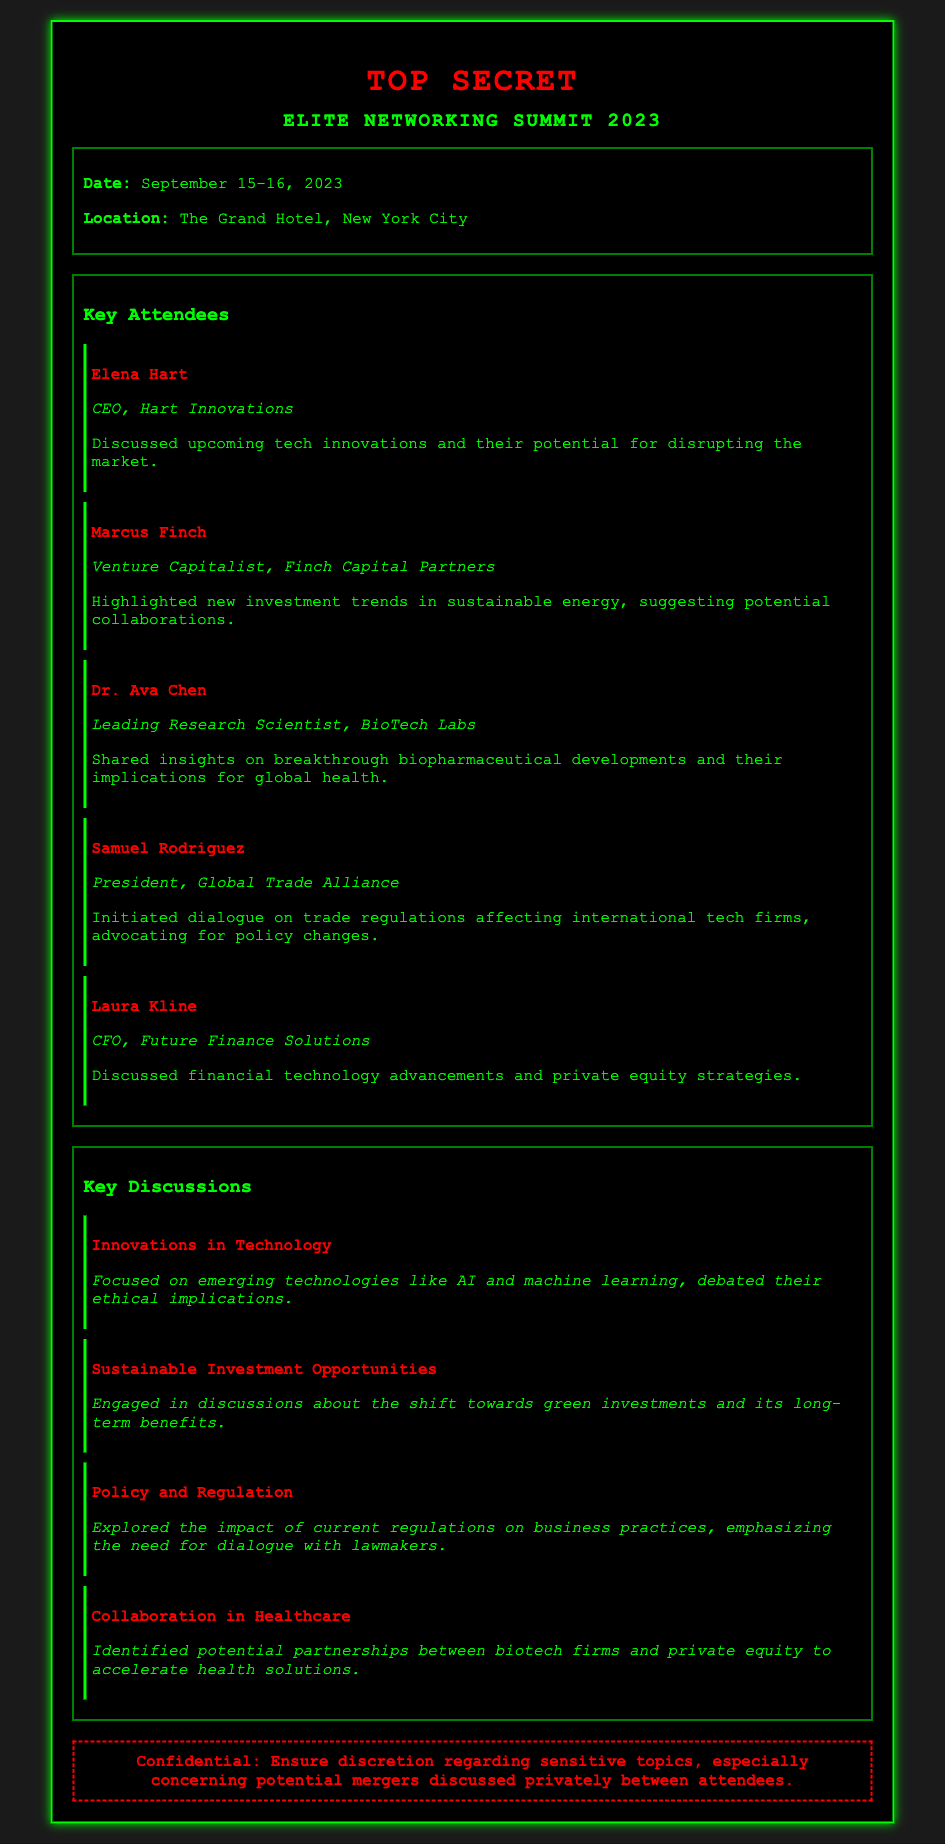What are the dates of the event? The dates of the event are stated clearly in the document under the event details section.
Answer: September 15-16, 2023 Who is the CEO of Hart Innovations? This information can be found in the key attendees section, where each attendee's name and title are listed.
Answer: Elena Hart What is the main topic of discussion regarding sustainable investment? The summary of the discussion on sustainable investment opportunities provides a clear indication of the main focus.
Answer: Green investments Which city hosted the networking event? The location of the event is mentioned in the document, providing a clear answer to this geographic inquiry.
Answer: New York City What role does Dr. Ava Chen hold? Dr. Ava Chen's title is detailed in the key attendees section, specifying her position.
Answer: Leading Research Scientist What was a critical discussion point among attendees? The document lists several key discussions, highlighting various significant topics addressed at the summit.
Answer: Innovations in Technology Which attendee initiated dialogue on trade regulations? This information can be retrieved from the key attendees section where individual roles and discussions are noted.
Answer: Samuel Rodriguez How did attendees perceive the impact of current regulations? The summary from the discussions section indicates the general sentiment regarding regulations.
Answer: Need for dialogue with lawmakers What is the theme regarding healthcare collaborations? The summary under key discussions highlights the essence of the conversation on healthcare collaborations.
Answer: Potential partnerships between biotech firms and private equity 